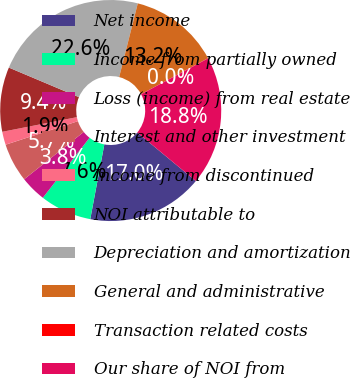<chart> <loc_0><loc_0><loc_500><loc_500><pie_chart><fcel>Net income<fcel>Income from partially owned<fcel>Loss (income) from real estate<fcel>Interest and other investment<fcel>Income from discontinued<fcel>NOI attributable to<fcel>Depreciation and amortization<fcel>General and administrative<fcel>Transaction related costs<fcel>Our share of NOI from<nl><fcel>16.96%<fcel>7.56%<fcel>3.8%<fcel>5.68%<fcel>1.92%<fcel>9.44%<fcel>22.6%<fcel>13.2%<fcel>0.04%<fcel>18.84%<nl></chart> 